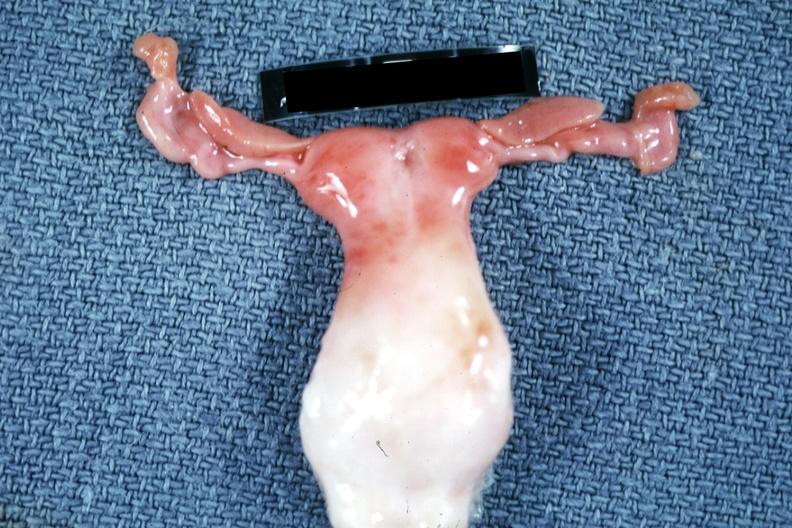does this image show infant bicornate uterus?
Answer the question using a single word or phrase. Yes 